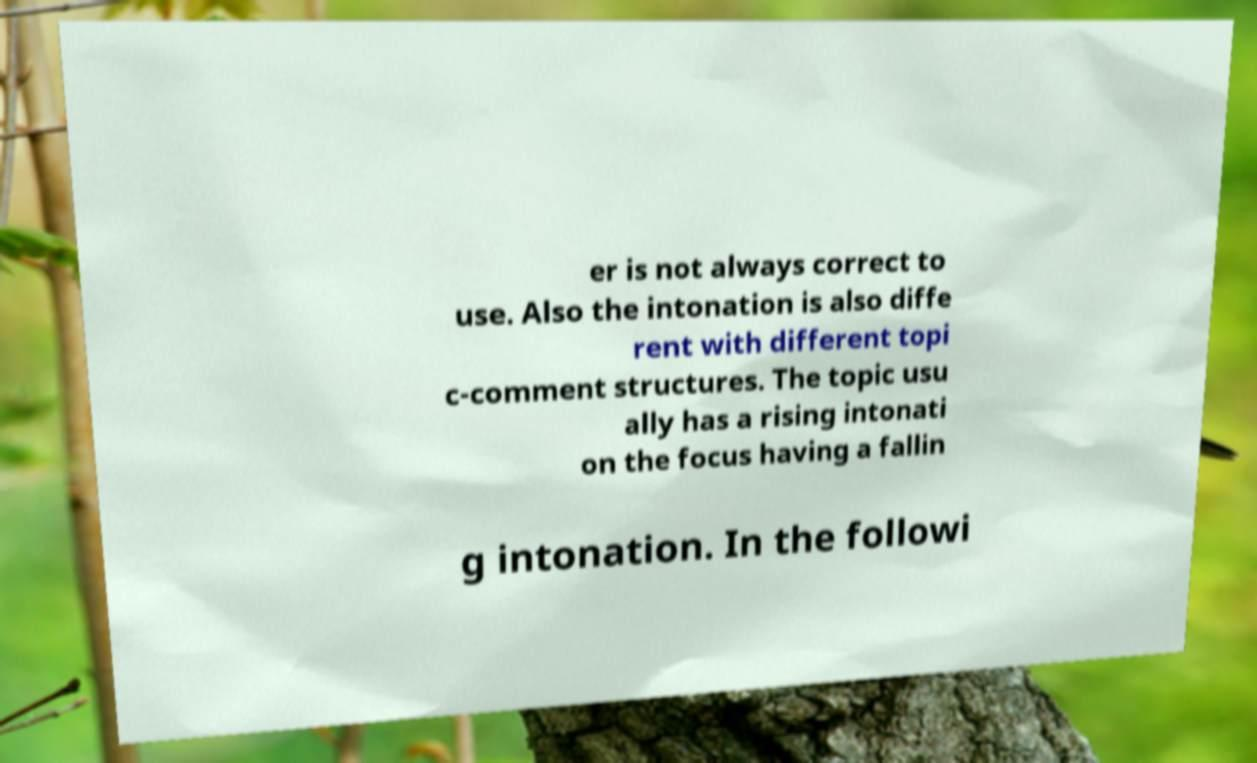Can you read and provide the text displayed in the image?This photo seems to have some interesting text. Can you extract and type it out for me? er is not always correct to use. Also the intonation is also diffe rent with different topi c-comment structures. The topic usu ally has a rising intonati on the focus having a fallin g intonation. In the followi 